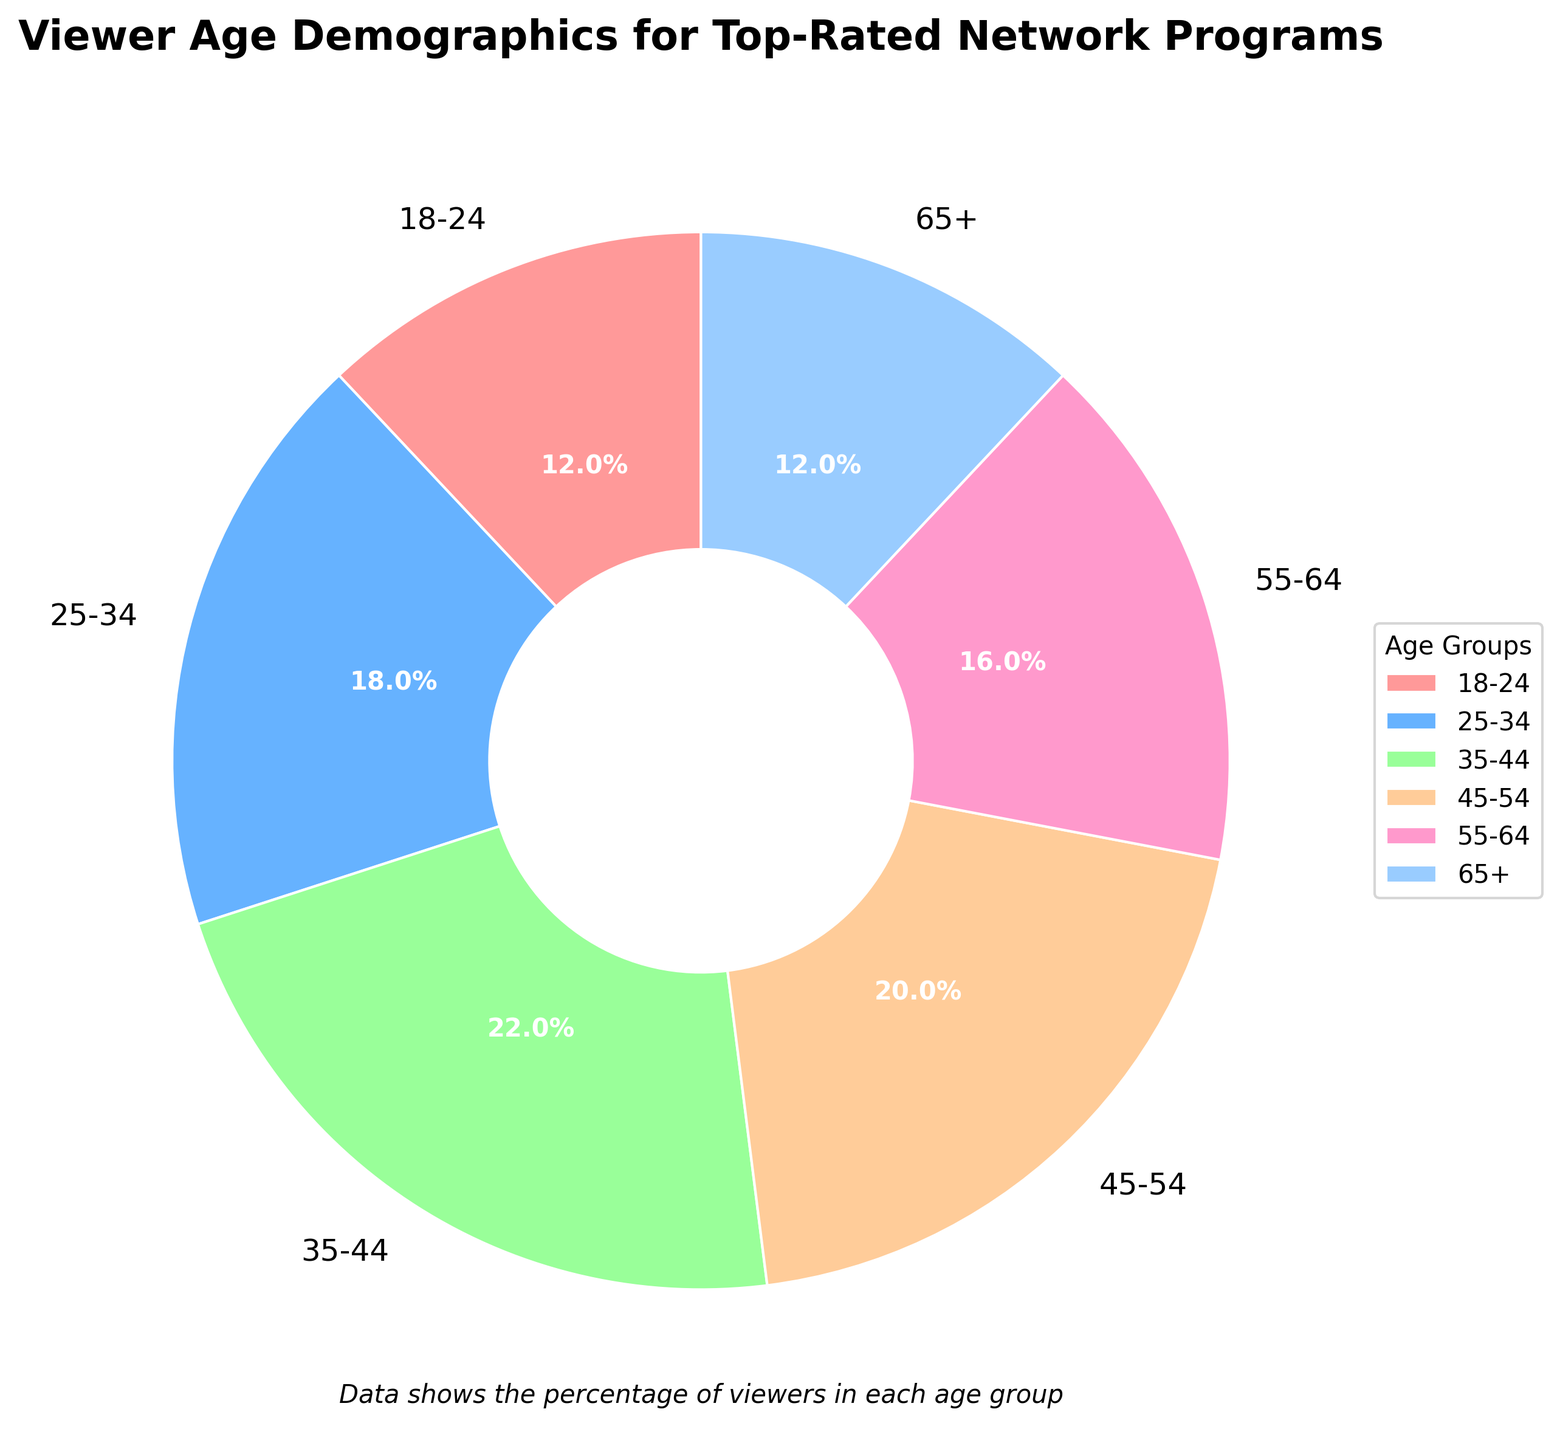Which age group has the highest percentage of viewers? The age group with the highest percentage is represented by the largest segment in the pie chart. This is the age group 35-44.
Answer: 35-44 Which two age groups have an equal percentage of viewers? The two age groups with an equal percentage will have segments of the same size. The age groups 18-24 and 65+ both have 12% of viewers.
Answer: 18-24 and 65+ What is the total percentage of viewers aged between 25-44? Sum the percentages of the age groups 25-34 and 35-44. That is 18% + 22% = 40%.
Answer: 40% How much more percentage of viewers are in the 35-44 group compared to the 55-64 group? Subtract the percentage of the 55-64 group from that of the 35-44 group. That is 22% - 16% = 6%.
Answer: 6% If the age groups 45-54 and 55-64 are combined into one age group, what would their combined percentage be? Sum the percentages of the 45-54 and 55-64 groups. That is 20% + 16% = 36%.
Answer: 36% Which age group has the smallest percentage of viewers? The age group with the smallest percentage is represented by the smallest segment in the pie chart. Both 18-24 and 65+ age groups have the smallest percentage, which is 12%.
Answer: 18-24 and 65+ What is the difference in viewership percentage between the youngest and oldest age groups? Subtract the percentage of the 65+ group from that of the 18-24 group. Both groups have 12% viewers, so the difference is 0%.
Answer: 0% What is the average percentage of viewers across all age groups? Sum the percentages of all age groups and then divide by the number of groups. The sum is 12% + 18% + 22% + 20% + 16% + 12% = 100%. The average is 100% / 6 = 16.67%.
Answer: 16.67% Which age group is represented by the blue segment in the pie chart? By observing the colors in the pie chart, the blue segment corresponds to the 25-34 age group.
Answer: 25-34 What percentage of viewers is represented by age groups under 34? Sum the percentages of the 18-24 and 25-34 groups. That is 12% + 18% = 30%.
Answer: 30% 